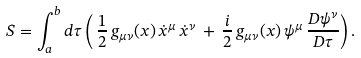Convert formula to latex. <formula><loc_0><loc_0><loc_500><loc_500>S = \int _ { a } ^ { b } d \tau \left ( \, { \frac { 1 } { 2 } } \, g _ { \mu \nu } ( x ) \, \dot { x } ^ { \mu } \, \dot { x } ^ { \nu } \, + \, { \frac { i } { 2 } } \, g _ { \mu \nu } ( x ) \, \psi ^ { \mu } \, { \frac { D \psi ^ { \nu } } { D \tau } } \right ) .</formula> 